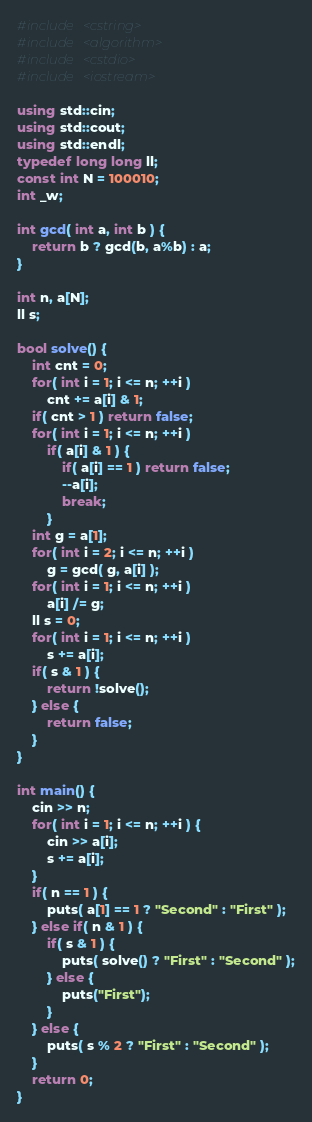Convert code to text. <code><loc_0><loc_0><loc_500><loc_500><_C++_>#include <cstring>
#include <algorithm>
#include <cstdio>
#include <iostream>

using std::cin;
using std::cout;
using std::endl;
typedef long long ll;
const int N = 100010;
int _w;

int gcd( int a, int b ) {
	return b ? gcd(b, a%b) : a;
}

int n, a[N];
ll s;

bool solve() {
	int cnt = 0;
	for( int i = 1; i <= n; ++i )
		cnt += a[i] & 1;
	if( cnt > 1 ) return false;
	for( int i = 1; i <= n; ++i )
		if( a[i] & 1 ) {
			if( a[i] == 1 ) return false;
			--a[i];
			break;
		}
	int g = a[1];
	for( int i = 2; i <= n; ++i )
		g = gcd( g, a[i] );
	for( int i = 1; i <= n; ++i )
		a[i] /= g;
	ll s = 0;
	for( int i = 1; i <= n; ++i )
		s += a[i];
	if( s & 1 ) {
		return !solve();
	} else {
		return false;
	}
}

int main() {
	cin >> n;
	for( int i = 1; i <= n; ++i ) {
		cin >> a[i];
		s += a[i];
	}
	if( n == 1 ) {
		puts( a[1] == 1 ? "Second" : "First" );
	} else if( n & 1 ) {
		if( s & 1 ) {
			puts( solve() ? "First" : "Second" );
		} else {
			puts("First");
		}
	} else {
		puts( s % 2 ? "First" : "Second" );
	}
	return 0;
}
</code> 